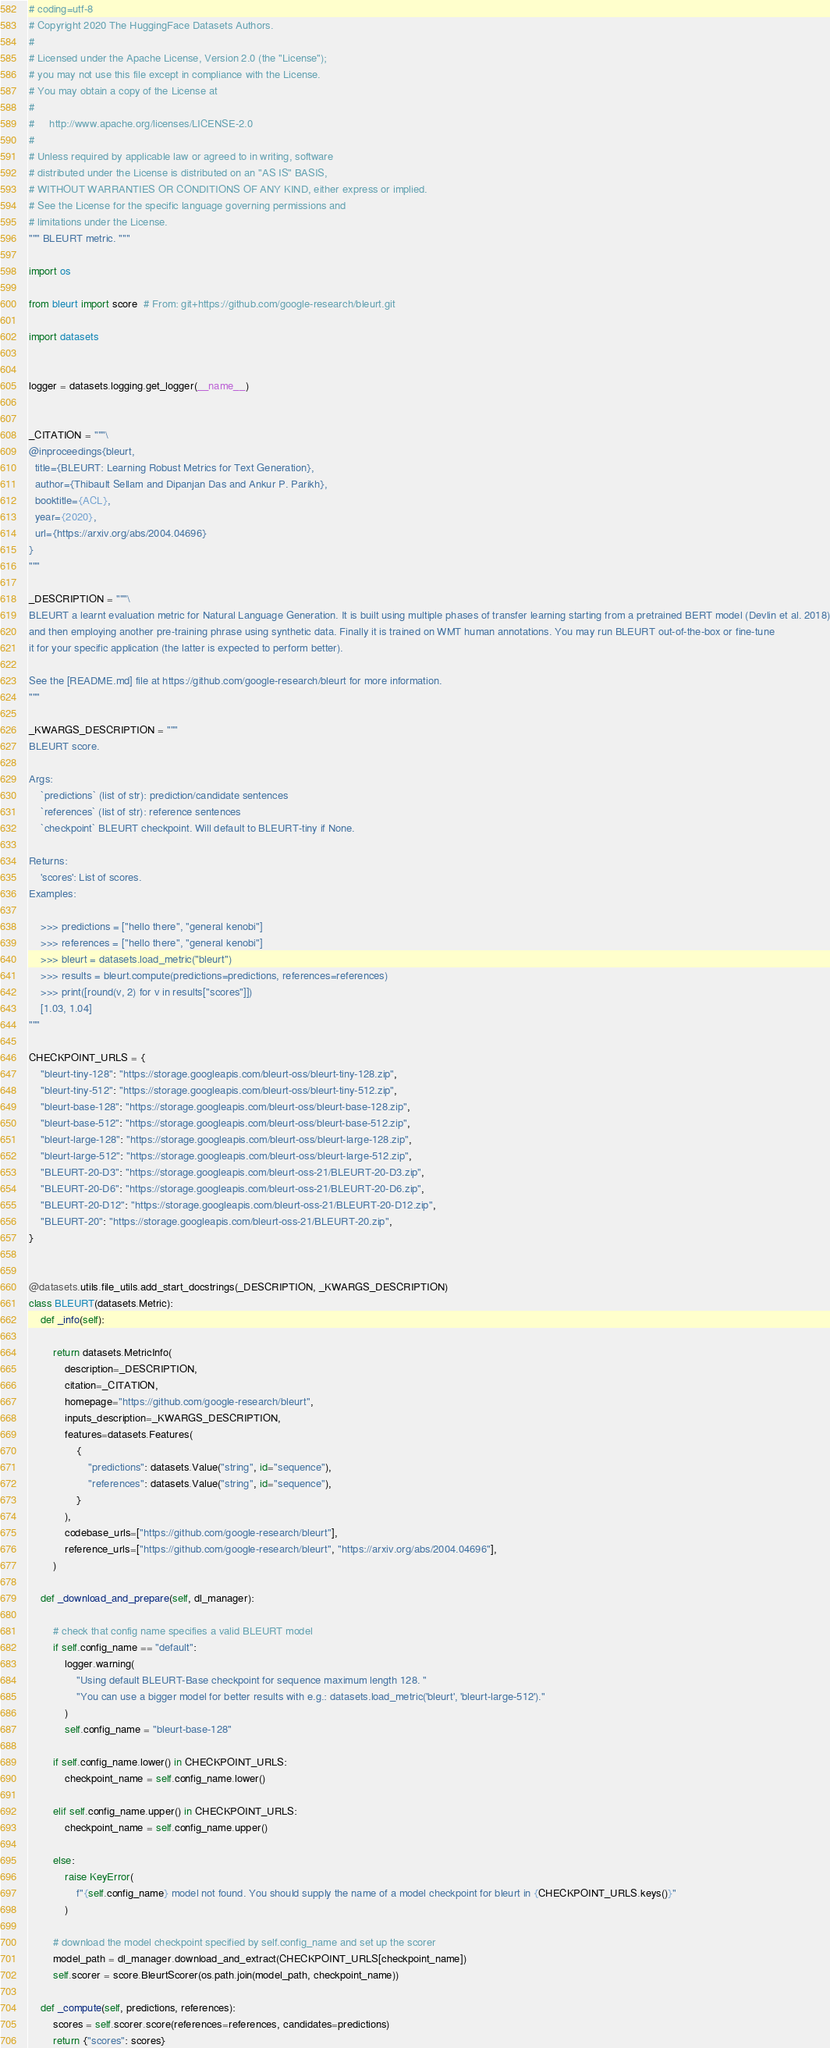Convert code to text. <code><loc_0><loc_0><loc_500><loc_500><_Python_># coding=utf-8
# Copyright 2020 The HuggingFace Datasets Authors.
#
# Licensed under the Apache License, Version 2.0 (the "License");
# you may not use this file except in compliance with the License.
# You may obtain a copy of the License at
#
#     http://www.apache.org/licenses/LICENSE-2.0
#
# Unless required by applicable law or agreed to in writing, software
# distributed under the License is distributed on an "AS IS" BASIS,
# WITHOUT WARRANTIES OR CONDITIONS OF ANY KIND, either express or implied.
# See the License for the specific language governing permissions and
# limitations under the License.
""" BLEURT metric. """

import os

from bleurt import score  # From: git+https://github.com/google-research/bleurt.git

import datasets


logger = datasets.logging.get_logger(__name__)


_CITATION = """\
@inproceedings{bleurt,
  title={BLEURT: Learning Robust Metrics for Text Generation},
  author={Thibault Sellam and Dipanjan Das and Ankur P. Parikh},
  booktitle={ACL},
  year={2020},
  url={https://arxiv.org/abs/2004.04696}
}
"""

_DESCRIPTION = """\
BLEURT a learnt evaluation metric for Natural Language Generation. It is built using multiple phases of transfer learning starting from a pretrained BERT model (Devlin et al. 2018)
and then employing another pre-training phrase using synthetic data. Finally it is trained on WMT human annotations. You may run BLEURT out-of-the-box or fine-tune
it for your specific application (the latter is expected to perform better).

See the [README.md] file at https://github.com/google-research/bleurt for more information.
"""

_KWARGS_DESCRIPTION = """
BLEURT score.

Args:
    `predictions` (list of str): prediction/candidate sentences
    `references` (list of str): reference sentences
    `checkpoint` BLEURT checkpoint. Will default to BLEURT-tiny if None.

Returns:
    'scores': List of scores.
Examples:

    >>> predictions = ["hello there", "general kenobi"]
    >>> references = ["hello there", "general kenobi"]
    >>> bleurt = datasets.load_metric("bleurt")
    >>> results = bleurt.compute(predictions=predictions, references=references)
    >>> print([round(v, 2) for v in results["scores"]])
    [1.03, 1.04]
"""

CHECKPOINT_URLS = {
    "bleurt-tiny-128": "https://storage.googleapis.com/bleurt-oss/bleurt-tiny-128.zip",
    "bleurt-tiny-512": "https://storage.googleapis.com/bleurt-oss/bleurt-tiny-512.zip",
    "bleurt-base-128": "https://storage.googleapis.com/bleurt-oss/bleurt-base-128.zip",
    "bleurt-base-512": "https://storage.googleapis.com/bleurt-oss/bleurt-base-512.zip",
    "bleurt-large-128": "https://storage.googleapis.com/bleurt-oss/bleurt-large-128.zip",
    "bleurt-large-512": "https://storage.googleapis.com/bleurt-oss/bleurt-large-512.zip",
    "BLEURT-20-D3": "https://storage.googleapis.com/bleurt-oss-21/BLEURT-20-D3.zip",
    "BLEURT-20-D6": "https://storage.googleapis.com/bleurt-oss-21/BLEURT-20-D6.zip",
    "BLEURT-20-D12": "https://storage.googleapis.com/bleurt-oss-21/BLEURT-20-D12.zip",
    "BLEURT-20": "https://storage.googleapis.com/bleurt-oss-21/BLEURT-20.zip",
}


@datasets.utils.file_utils.add_start_docstrings(_DESCRIPTION, _KWARGS_DESCRIPTION)
class BLEURT(datasets.Metric):
    def _info(self):

        return datasets.MetricInfo(
            description=_DESCRIPTION,
            citation=_CITATION,
            homepage="https://github.com/google-research/bleurt",
            inputs_description=_KWARGS_DESCRIPTION,
            features=datasets.Features(
                {
                    "predictions": datasets.Value("string", id="sequence"),
                    "references": datasets.Value("string", id="sequence"),
                }
            ),
            codebase_urls=["https://github.com/google-research/bleurt"],
            reference_urls=["https://github.com/google-research/bleurt", "https://arxiv.org/abs/2004.04696"],
        )

    def _download_and_prepare(self, dl_manager):

        # check that config name specifies a valid BLEURT model
        if self.config_name == "default":
            logger.warning(
                "Using default BLEURT-Base checkpoint for sequence maximum length 128. "
                "You can use a bigger model for better results with e.g.: datasets.load_metric('bleurt', 'bleurt-large-512')."
            )
            self.config_name = "bleurt-base-128"

        if self.config_name.lower() in CHECKPOINT_URLS:
            checkpoint_name = self.config_name.lower()

        elif self.config_name.upper() in CHECKPOINT_URLS:
            checkpoint_name = self.config_name.upper()

        else:
            raise KeyError(
                f"{self.config_name} model not found. You should supply the name of a model checkpoint for bleurt in {CHECKPOINT_URLS.keys()}"
            )

        # download the model checkpoint specified by self.config_name and set up the scorer
        model_path = dl_manager.download_and_extract(CHECKPOINT_URLS[checkpoint_name])
        self.scorer = score.BleurtScorer(os.path.join(model_path, checkpoint_name))

    def _compute(self, predictions, references):
        scores = self.scorer.score(references=references, candidates=predictions)
        return {"scores": scores}
</code> 